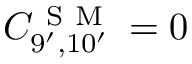Convert formula to latex. <formula><loc_0><loc_0><loc_500><loc_500>C _ { 9 ^ { \prime } , 1 0 ^ { \prime } } ^ { S M } = 0</formula> 